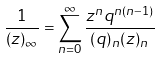<formula> <loc_0><loc_0><loc_500><loc_500>\frac { 1 } { ( z ) _ { \infty } } = \sum _ { n = 0 } ^ { \infty } \frac { z ^ { n } q ^ { n ( n - 1 ) } } { ( q ) _ { n } ( z ) _ { n } }</formula> 